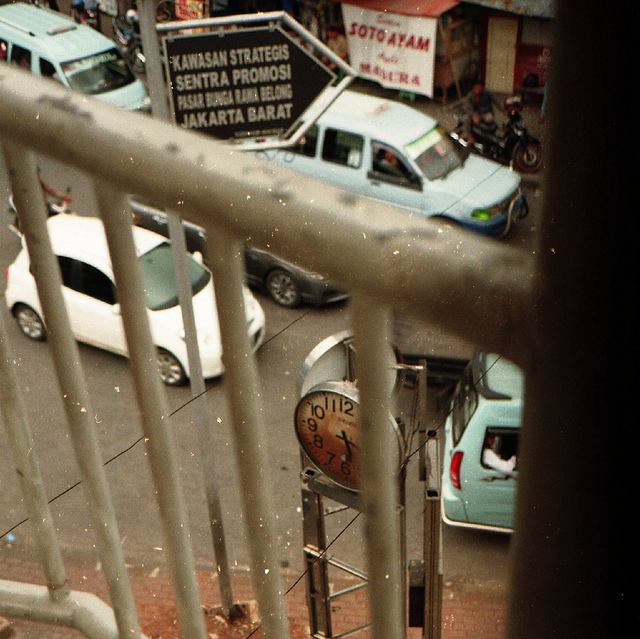Identify the text displayed in this image. KAWASAN STRATEGIS PROMOSI SENTRA JAKARTA 7 6 7 8 9 10 11 2 SOTOAYAM BELONG BARAT 